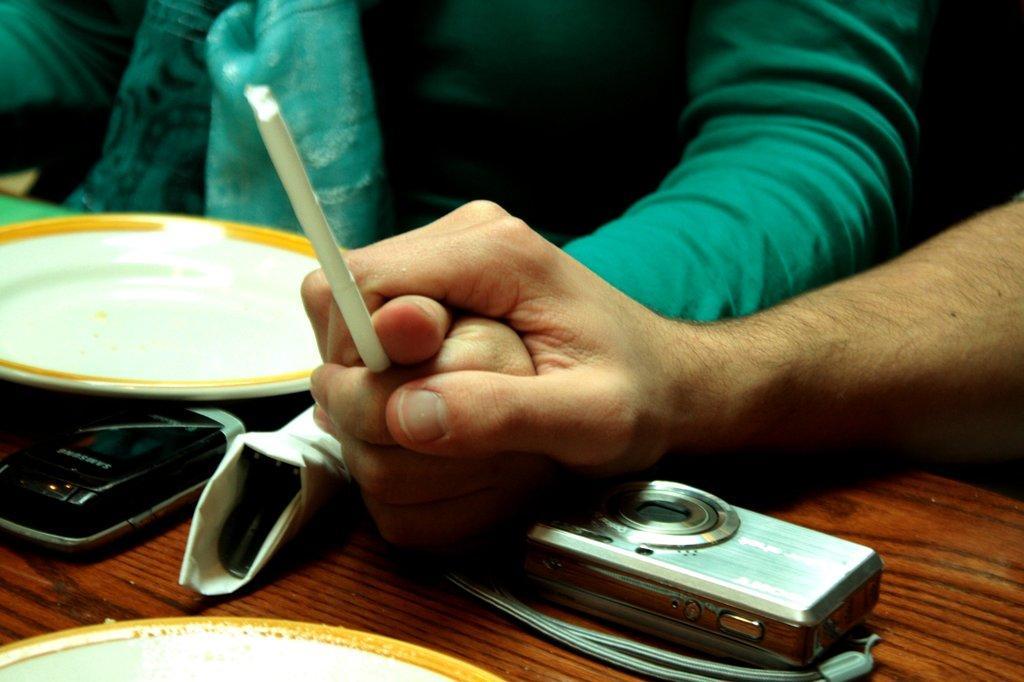Describe this image in one or two sentences. In this image we can see a person holding another person's hand. There is a camera, mobile phone and plate on the table. 